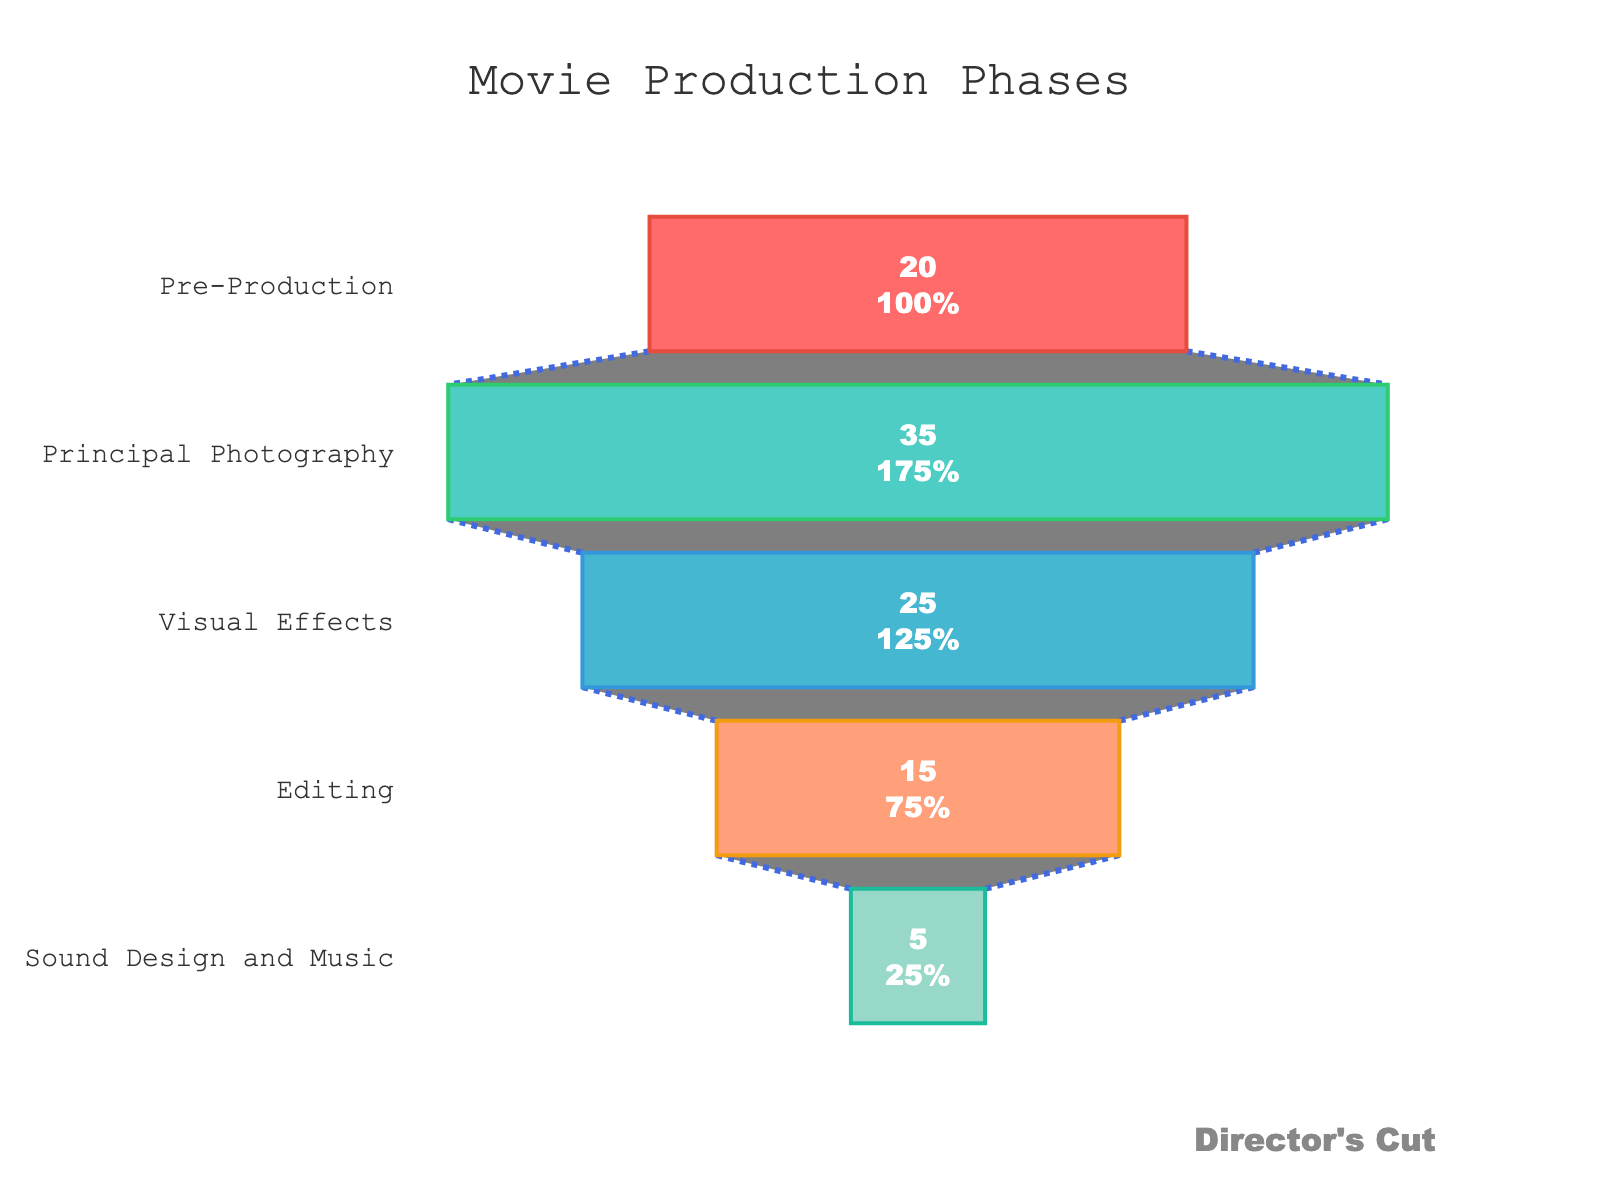What is the title of the figure? The title is displayed at the top center of the figure.
Answer: Movie Production Phases Which stage of movie production takes the most time? By looking at the largest section in the funnel chart, we can identify the stage with the highest percentage.
Answer: Principal Photography What is the total percentage of time spent on Visual Effects and Editing combined? Add the percentages of Visual Effects (25%) and Editing (15%). 25% + 15% = 40%
Answer: 40% Which production stage occupies the smallest percentage of time? Identify the smallest section in the funnel chart.
Answer: Sound Design and Music How do the percentages of time spent on Pre-Production and Principal Photography compare? Compare the values of Pre-Production (20%) and Principal Photography (35%).
Answer: Principal Photography is greater than Pre-Production What is the difference in percentage between the stage with the highest time and the stage with the lowest time? Subtract the smallest percentage (Sound Design and Music, 5%) from the largest percentage (Principal Photography, 35%). 35% - 5% = 30%
Answer: 30% Which color is used to represent the Visual Effects stage? Look for the color associated with Visual Effects in the funnel chart.
Answer: Light blue How much more time is spent on Principal Photography compared to Editing? Subtract the percentage of Editing (15%) from Principal Photography (35%). 35% - 15% = 20%
Answer: 20% How many production stages are depicted in the chart? Count the distinct stages in the funnel chart.
Answer: 5 What percentage of time is allocated to Sound Design and Music and where is it located in the funnel? The funnel chart shows Sound Design and Music at the bottom with its percentage indicated.
Answer: 5%, located at the bottom 